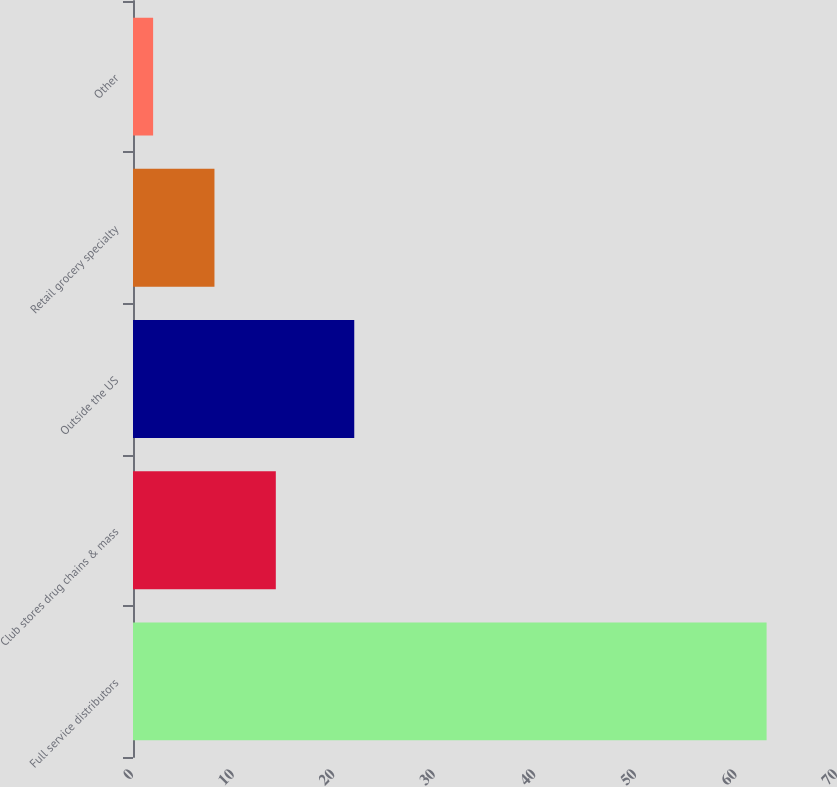<chart> <loc_0><loc_0><loc_500><loc_500><bar_chart><fcel>Full service distributors<fcel>Club stores drug chains & mass<fcel>Outside the US<fcel>Retail grocery specialty<fcel>Other<nl><fcel>63<fcel>14.2<fcel>22<fcel>8.1<fcel>2<nl></chart> 